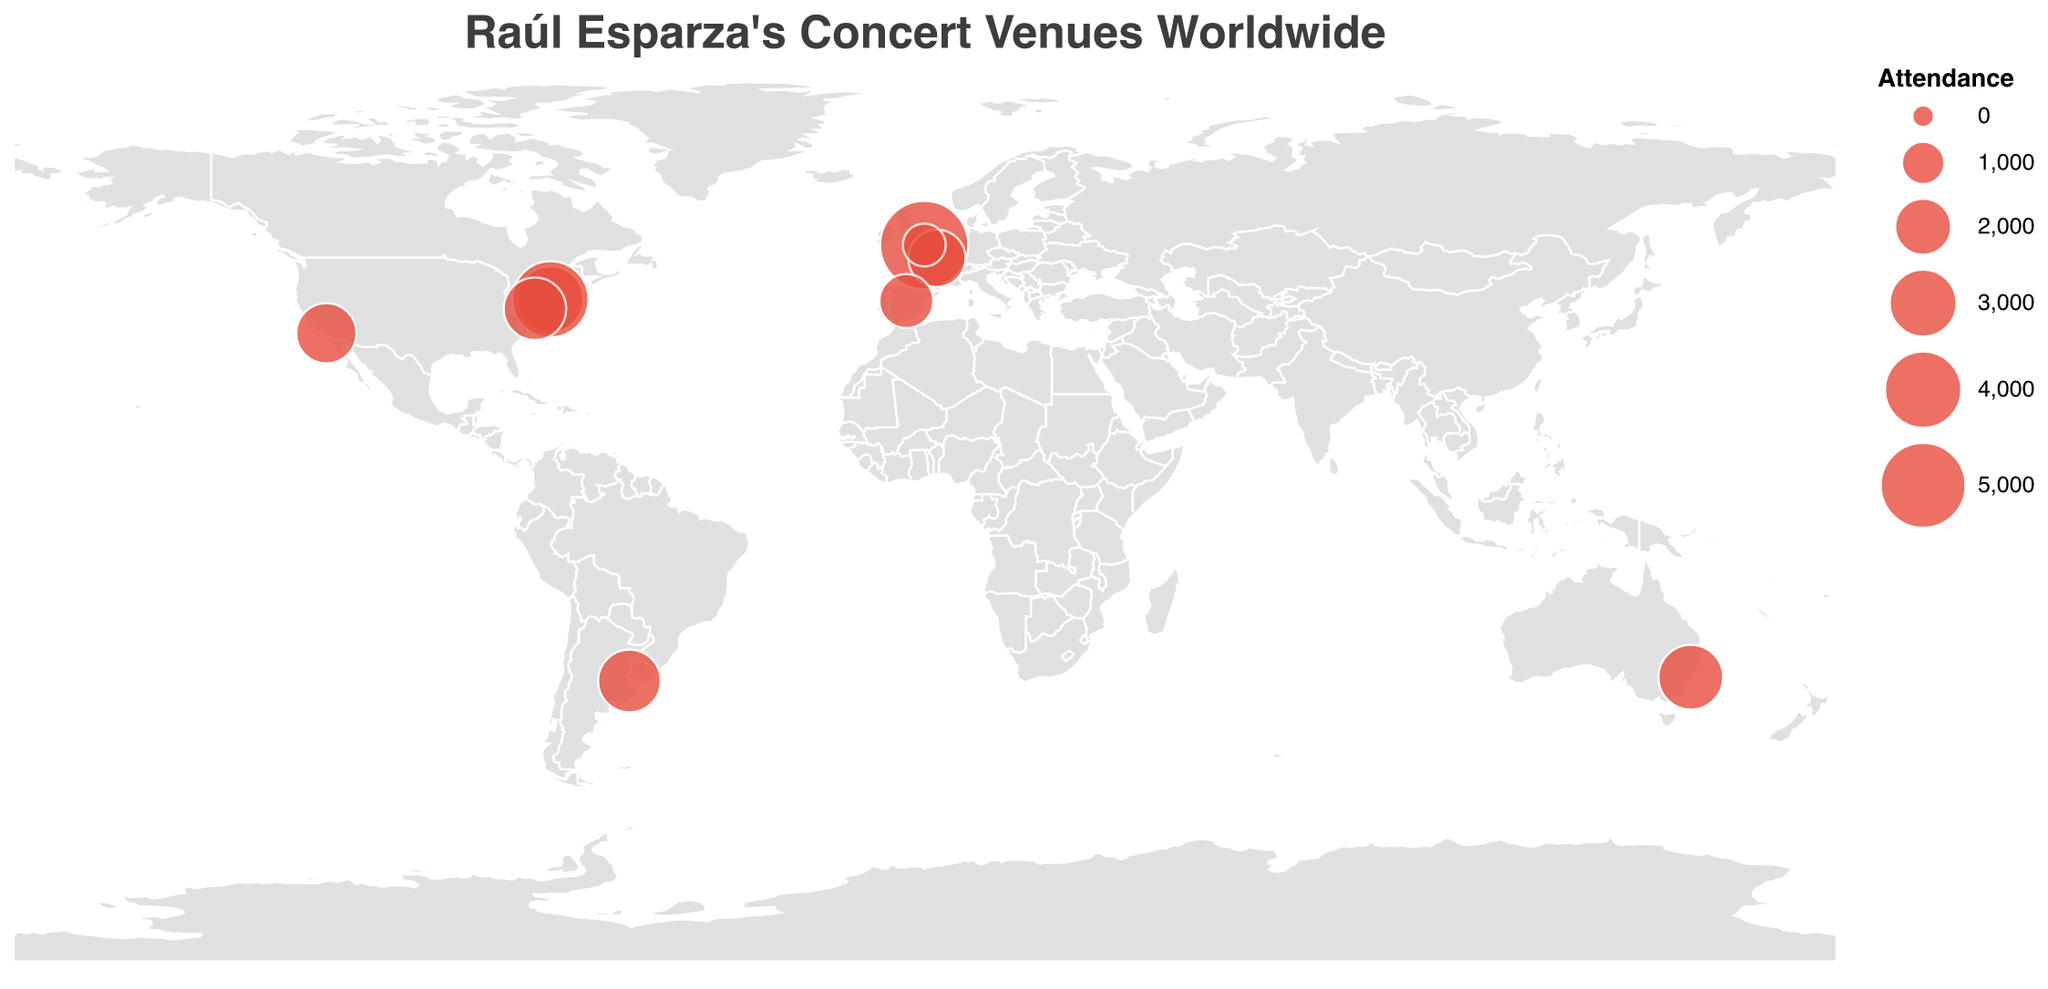How many concert venues are displayed on the map? Count the number of circles shown on the map representing the venues. Each circle corresponds to one venue.
Answer: 10 Which venue had the highest attendance for Raúl Esparza’s concert tours and live performances? Look for the largest circle on the map, which represents the venue with the highest attendance.
Answer: Royal Albert Hall What is the total attendance for Raúl Esparza’s concerts at venues in the USA? Add the attendance figures for venues in the USA. These venues are Carnegie Hall (2804), Lincoln Center (3850), Walt Disney Concert Hall (2265), and Kennedy Center (2465). So, 2804 + 3850 + 2265 + 2465 = 11384.
Answer: 11384 Which city hosted Raúl Esparza’s concerts in more than one venue and what are those venues? Identify cities with more than one circle on the map. New York City hosted concerts at Carnegie Hall and Lincoln Center.
Answer: New York City (Carnegie Hall, Lincoln Center) What is the average attendance for Raúl Esparza’s concerts in European venues? Calculate the average by summing the attendance figures for European venues and dividing by the number of venues. European venues are Royal Albert Hall (5272), Cadogan Hall (953), Théâtre du Châtelet (2010), and Teatro Real (1746). So, the sum is 5272 + 953 + 2010 + 1746 = 9971, and the average is 9971 / 4 = 2492.75.
Answer: 2492.75 Compare the attendance of concerts in Sydney and Buenos Aires. Which city had a higher attendance? Check the attendance figures for the venues in Sydney (2679) and Buenos Aires (2487) and compare them.
Answer: Sydney Which venue in New York City had the higher attendance, Carnegie Hall or Lincoln Center? Compare the attendance figures for Carnegie Hall (2804) and Lincoln Center (3850).
Answer: Lincoln Center Based on the geographic plot, what is the primary color used for the map background? Observe the fill color of the geographical shapes on the map.
Answer: Light gray (or #e0e0e0) Identify the non-European venue with the smallest attendance and its city. Look for the smallest circle outside Europe and check its venue and city. The smallest non-European venue (outside Europe) is Walt Disney Concert Hall in Los Angeles with an attendance of 2265.
Answer: Walt Disney Concert Hall, Los Angeles 